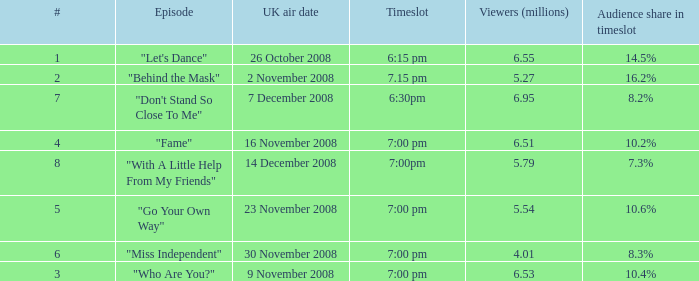Name the timeslot for 6.51 viewers 7:00 pm. 